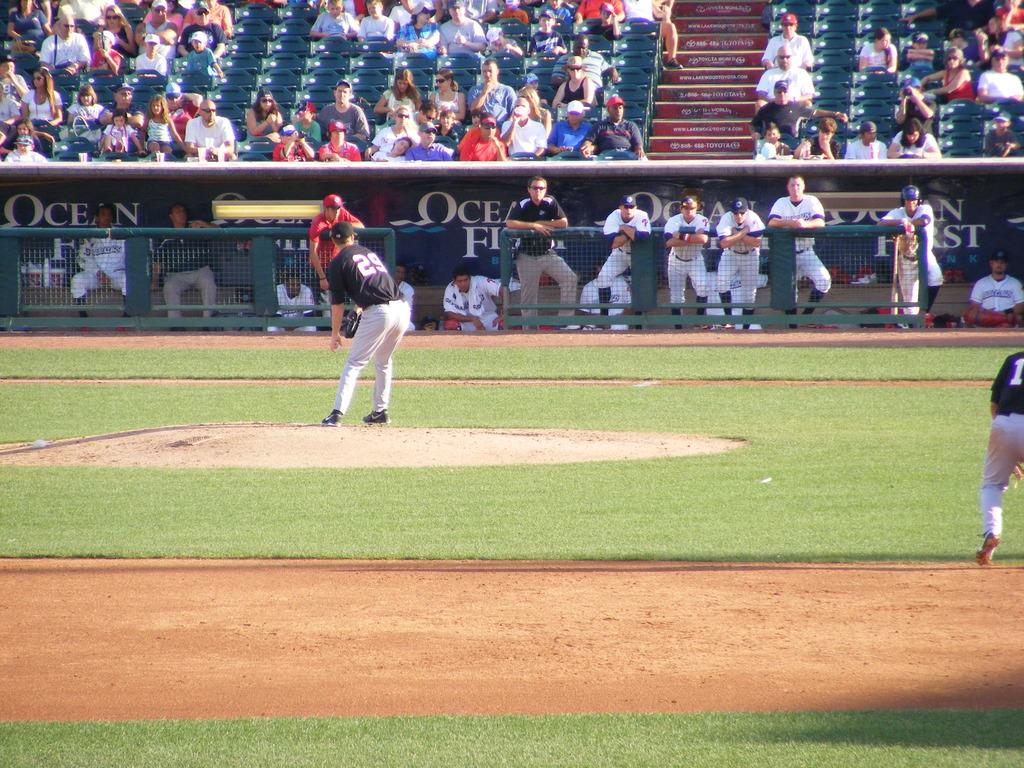What name for a body of open water is on the blue background behind the dugouts?
Offer a very short reply. Ocean. 